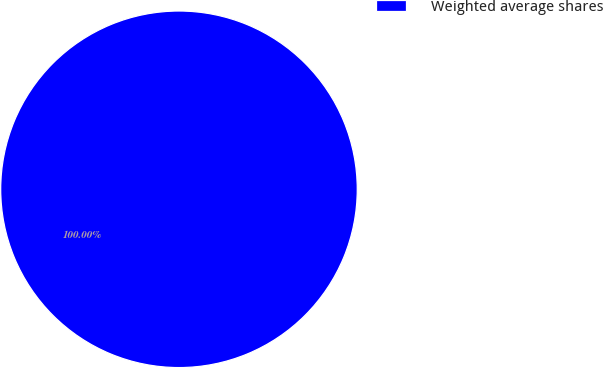<chart> <loc_0><loc_0><loc_500><loc_500><pie_chart><fcel>Weighted average shares<nl><fcel>100.0%<nl></chart> 